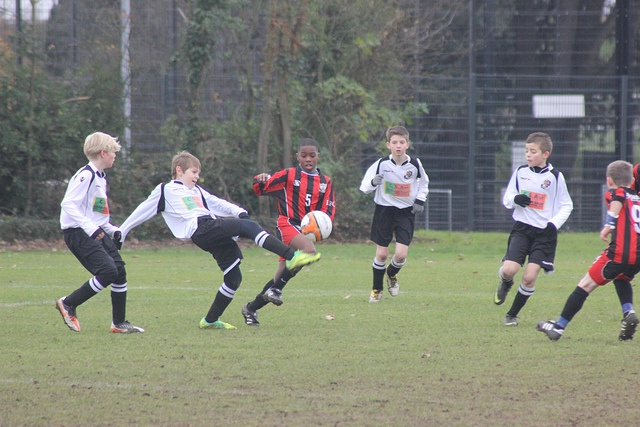Describe the objects in this image and their specific colors. I can see people in lightgray, lavender, gray, black, and darkgray tones, people in lightgray, lavender, gray, and black tones, people in lightgray, lavender, gray, black, and darkgray tones, people in lightgray, gray, black, salmon, and darkgray tones, and people in lightgray, lavender, darkgray, black, and gray tones in this image. 